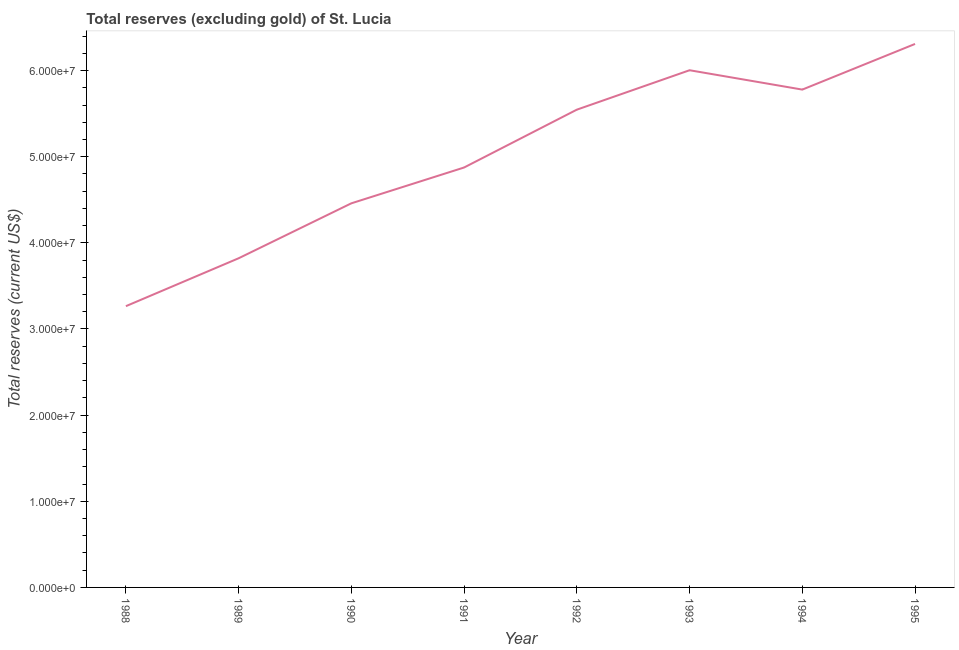What is the total reserves (excluding gold) in 1989?
Your answer should be compact. 3.82e+07. Across all years, what is the maximum total reserves (excluding gold)?
Offer a very short reply. 6.31e+07. Across all years, what is the minimum total reserves (excluding gold)?
Make the answer very short. 3.26e+07. What is the sum of the total reserves (excluding gold)?
Provide a succinct answer. 4.01e+08. What is the difference between the total reserves (excluding gold) in 1990 and 1991?
Ensure brevity in your answer.  -4.16e+06. What is the average total reserves (excluding gold) per year?
Offer a very short reply. 5.01e+07. What is the median total reserves (excluding gold)?
Your answer should be very brief. 5.21e+07. What is the ratio of the total reserves (excluding gold) in 1988 to that in 1989?
Keep it short and to the point. 0.85. What is the difference between the highest and the second highest total reserves (excluding gold)?
Offer a terse response. 3.05e+06. Is the sum of the total reserves (excluding gold) in 1990 and 1995 greater than the maximum total reserves (excluding gold) across all years?
Give a very brief answer. Yes. What is the difference between the highest and the lowest total reserves (excluding gold)?
Your answer should be very brief. 3.04e+07. In how many years, is the total reserves (excluding gold) greater than the average total reserves (excluding gold) taken over all years?
Give a very brief answer. 4. Does the total reserves (excluding gold) monotonically increase over the years?
Ensure brevity in your answer.  No. How many years are there in the graph?
Your answer should be compact. 8. What is the difference between two consecutive major ticks on the Y-axis?
Provide a succinct answer. 1.00e+07. Does the graph contain grids?
Make the answer very short. No. What is the title of the graph?
Your response must be concise. Total reserves (excluding gold) of St. Lucia. What is the label or title of the X-axis?
Give a very brief answer. Year. What is the label or title of the Y-axis?
Ensure brevity in your answer.  Total reserves (current US$). What is the Total reserves (current US$) of 1988?
Your answer should be very brief. 3.26e+07. What is the Total reserves (current US$) of 1989?
Your answer should be very brief. 3.82e+07. What is the Total reserves (current US$) in 1990?
Your answer should be compact. 4.46e+07. What is the Total reserves (current US$) in 1991?
Offer a very short reply. 4.87e+07. What is the Total reserves (current US$) in 1992?
Ensure brevity in your answer.  5.55e+07. What is the Total reserves (current US$) of 1993?
Keep it short and to the point. 6.00e+07. What is the Total reserves (current US$) in 1994?
Offer a very short reply. 5.78e+07. What is the Total reserves (current US$) in 1995?
Offer a very short reply. 6.31e+07. What is the difference between the Total reserves (current US$) in 1988 and 1989?
Keep it short and to the point. -5.56e+06. What is the difference between the Total reserves (current US$) in 1988 and 1990?
Give a very brief answer. -1.19e+07. What is the difference between the Total reserves (current US$) in 1988 and 1991?
Your response must be concise. -1.61e+07. What is the difference between the Total reserves (current US$) in 1988 and 1992?
Offer a terse response. -2.28e+07. What is the difference between the Total reserves (current US$) in 1988 and 1993?
Make the answer very short. -2.74e+07. What is the difference between the Total reserves (current US$) in 1988 and 1994?
Offer a terse response. -2.51e+07. What is the difference between the Total reserves (current US$) in 1988 and 1995?
Keep it short and to the point. -3.04e+07. What is the difference between the Total reserves (current US$) in 1989 and 1990?
Make the answer very short. -6.38e+06. What is the difference between the Total reserves (current US$) in 1989 and 1991?
Offer a very short reply. -1.05e+07. What is the difference between the Total reserves (current US$) in 1989 and 1992?
Offer a terse response. -1.73e+07. What is the difference between the Total reserves (current US$) in 1989 and 1993?
Give a very brief answer. -2.18e+07. What is the difference between the Total reserves (current US$) in 1989 and 1994?
Provide a short and direct response. -1.96e+07. What is the difference between the Total reserves (current US$) in 1989 and 1995?
Your answer should be compact. -2.49e+07. What is the difference between the Total reserves (current US$) in 1990 and 1991?
Your response must be concise. -4.16e+06. What is the difference between the Total reserves (current US$) in 1990 and 1992?
Offer a terse response. -1.09e+07. What is the difference between the Total reserves (current US$) in 1990 and 1993?
Give a very brief answer. -1.54e+07. What is the difference between the Total reserves (current US$) in 1990 and 1994?
Provide a short and direct response. -1.32e+07. What is the difference between the Total reserves (current US$) in 1990 and 1995?
Provide a short and direct response. -1.85e+07. What is the difference between the Total reserves (current US$) in 1991 and 1992?
Make the answer very short. -6.71e+06. What is the difference between the Total reserves (current US$) in 1991 and 1993?
Give a very brief answer. -1.13e+07. What is the difference between the Total reserves (current US$) in 1991 and 1994?
Offer a very short reply. -9.04e+06. What is the difference between the Total reserves (current US$) in 1991 and 1995?
Ensure brevity in your answer.  -1.43e+07. What is the difference between the Total reserves (current US$) in 1992 and 1993?
Give a very brief answer. -4.58e+06. What is the difference between the Total reserves (current US$) in 1992 and 1994?
Your answer should be compact. -2.33e+06. What is the difference between the Total reserves (current US$) in 1992 and 1995?
Keep it short and to the point. -7.63e+06. What is the difference between the Total reserves (current US$) in 1993 and 1994?
Your response must be concise. 2.25e+06. What is the difference between the Total reserves (current US$) in 1993 and 1995?
Ensure brevity in your answer.  -3.05e+06. What is the difference between the Total reserves (current US$) in 1994 and 1995?
Your answer should be compact. -5.30e+06. What is the ratio of the Total reserves (current US$) in 1988 to that in 1989?
Provide a short and direct response. 0.85. What is the ratio of the Total reserves (current US$) in 1988 to that in 1990?
Provide a succinct answer. 0.73. What is the ratio of the Total reserves (current US$) in 1988 to that in 1991?
Provide a succinct answer. 0.67. What is the ratio of the Total reserves (current US$) in 1988 to that in 1992?
Ensure brevity in your answer.  0.59. What is the ratio of the Total reserves (current US$) in 1988 to that in 1993?
Give a very brief answer. 0.54. What is the ratio of the Total reserves (current US$) in 1988 to that in 1994?
Give a very brief answer. 0.56. What is the ratio of the Total reserves (current US$) in 1988 to that in 1995?
Give a very brief answer. 0.52. What is the ratio of the Total reserves (current US$) in 1989 to that in 1990?
Keep it short and to the point. 0.86. What is the ratio of the Total reserves (current US$) in 1989 to that in 1991?
Provide a short and direct response. 0.78. What is the ratio of the Total reserves (current US$) in 1989 to that in 1992?
Keep it short and to the point. 0.69. What is the ratio of the Total reserves (current US$) in 1989 to that in 1993?
Your answer should be compact. 0.64. What is the ratio of the Total reserves (current US$) in 1989 to that in 1994?
Your answer should be very brief. 0.66. What is the ratio of the Total reserves (current US$) in 1989 to that in 1995?
Provide a succinct answer. 0.61. What is the ratio of the Total reserves (current US$) in 1990 to that in 1991?
Your answer should be very brief. 0.92. What is the ratio of the Total reserves (current US$) in 1990 to that in 1992?
Your answer should be compact. 0.8. What is the ratio of the Total reserves (current US$) in 1990 to that in 1993?
Your response must be concise. 0.74. What is the ratio of the Total reserves (current US$) in 1990 to that in 1994?
Your response must be concise. 0.77. What is the ratio of the Total reserves (current US$) in 1990 to that in 1995?
Your answer should be compact. 0.71. What is the ratio of the Total reserves (current US$) in 1991 to that in 1992?
Offer a terse response. 0.88. What is the ratio of the Total reserves (current US$) in 1991 to that in 1993?
Your response must be concise. 0.81. What is the ratio of the Total reserves (current US$) in 1991 to that in 1994?
Provide a succinct answer. 0.84. What is the ratio of the Total reserves (current US$) in 1991 to that in 1995?
Keep it short and to the point. 0.77. What is the ratio of the Total reserves (current US$) in 1992 to that in 1993?
Your response must be concise. 0.92. What is the ratio of the Total reserves (current US$) in 1992 to that in 1994?
Your response must be concise. 0.96. What is the ratio of the Total reserves (current US$) in 1992 to that in 1995?
Keep it short and to the point. 0.88. What is the ratio of the Total reserves (current US$) in 1993 to that in 1994?
Make the answer very short. 1.04. What is the ratio of the Total reserves (current US$) in 1993 to that in 1995?
Your response must be concise. 0.95. What is the ratio of the Total reserves (current US$) in 1994 to that in 1995?
Offer a very short reply. 0.92. 